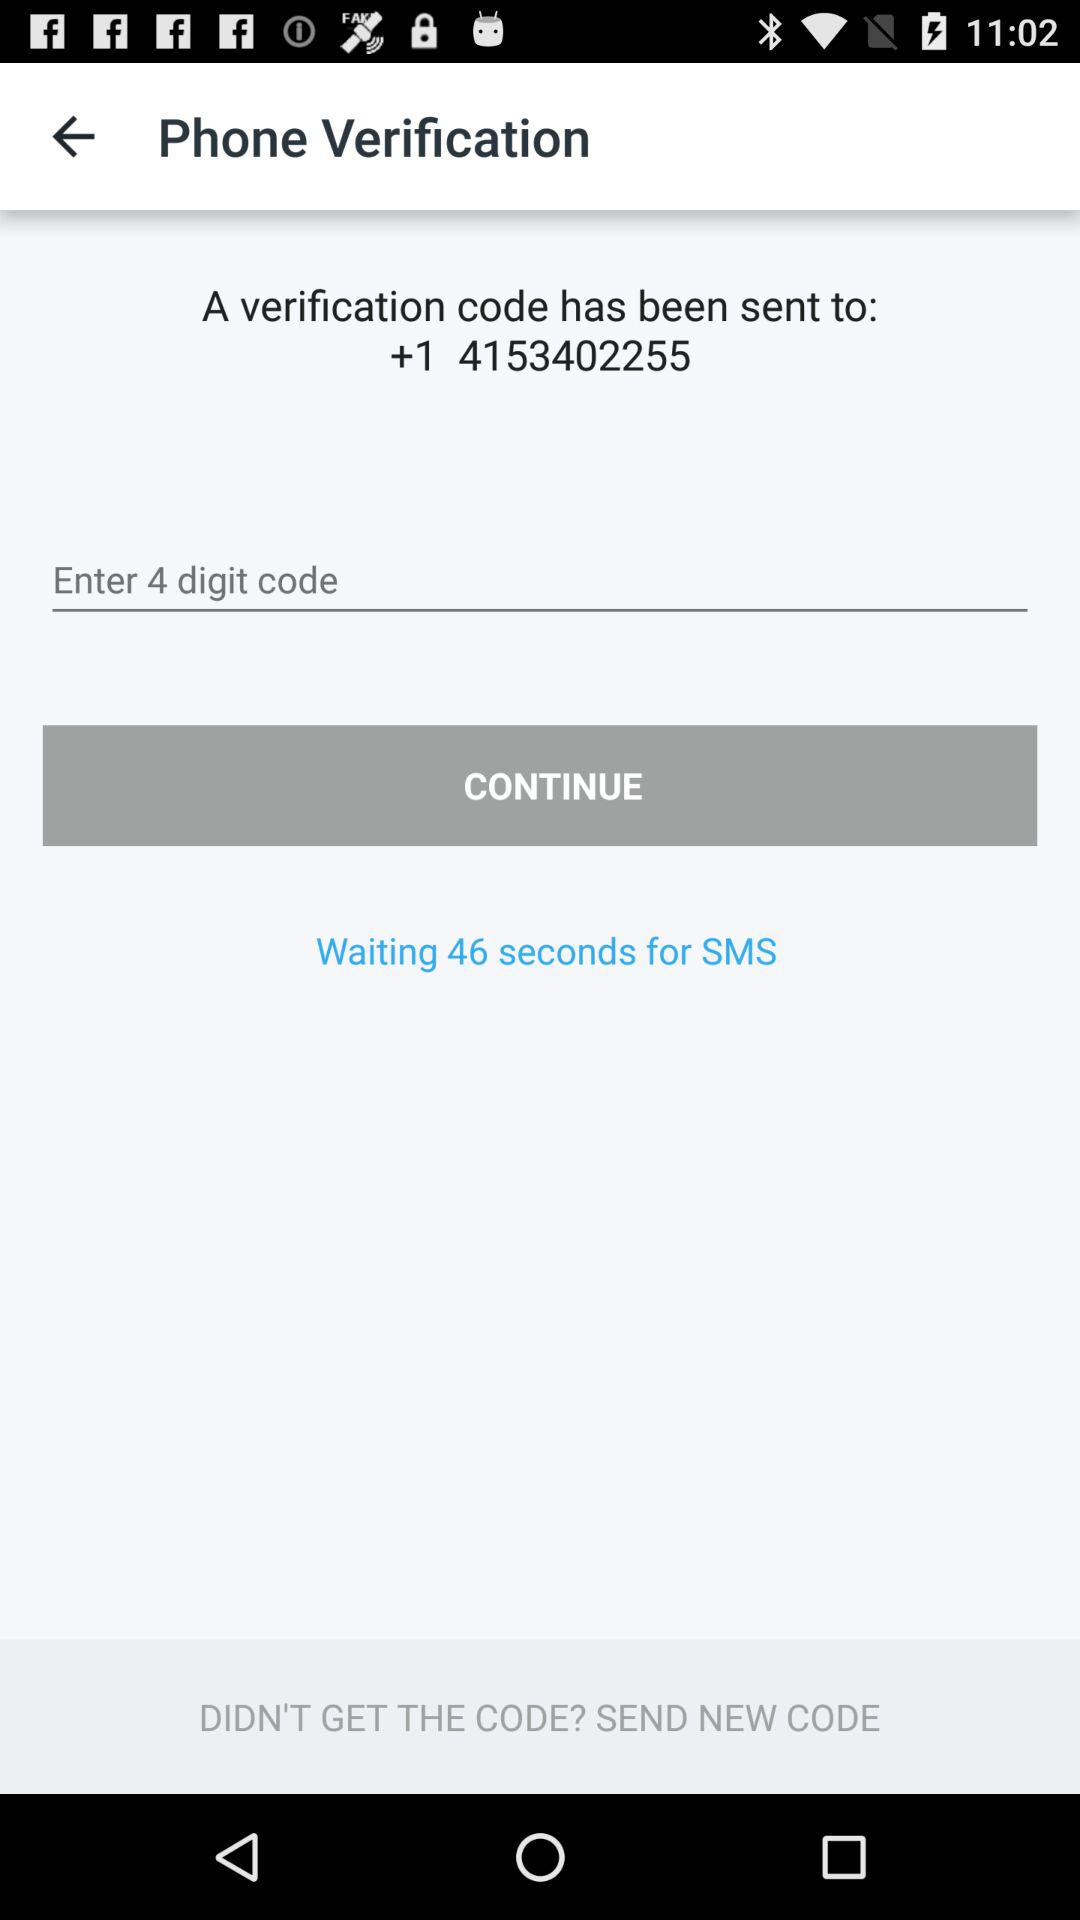How many seconds is the user waiting for the SMS?
Answer the question using a single word or phrase. 46 